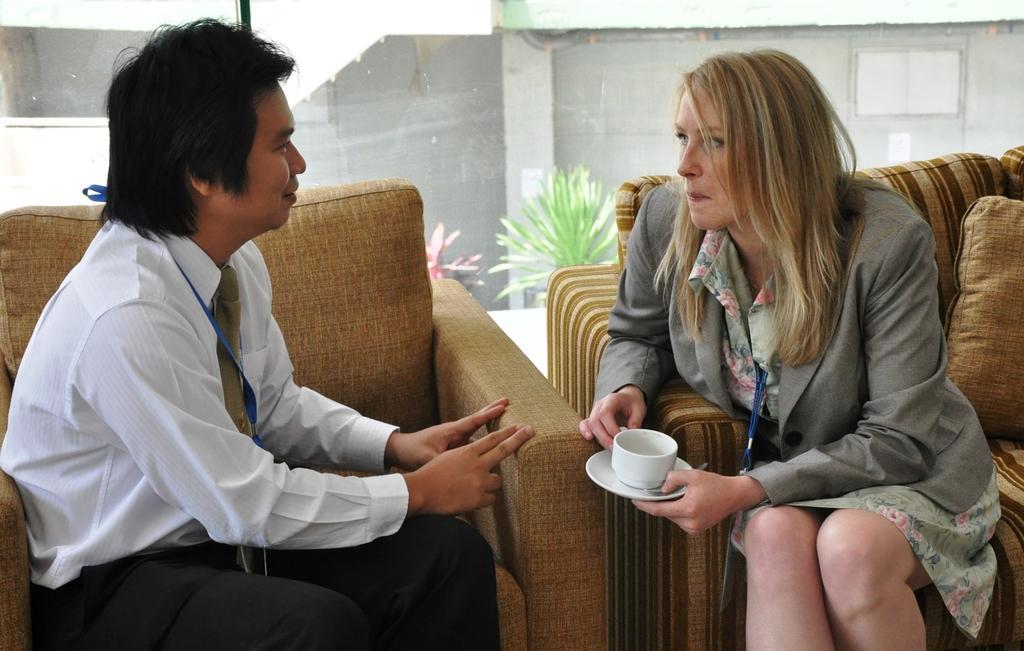Can you describe this image briefly? In this image I see a man and a woman who are sitting on sofa and this woman is holding a cup and saucer. In the background I see plants. 